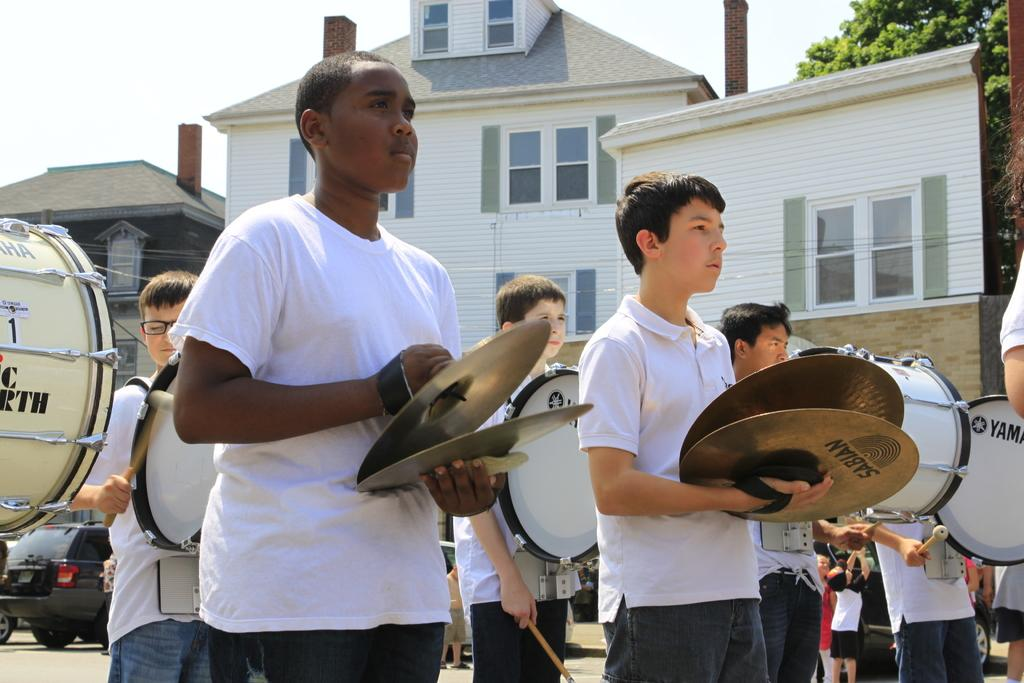<image>
Create a compact narrative representing the image presented. A group of students in a marching band the symbols are made by Sabian 